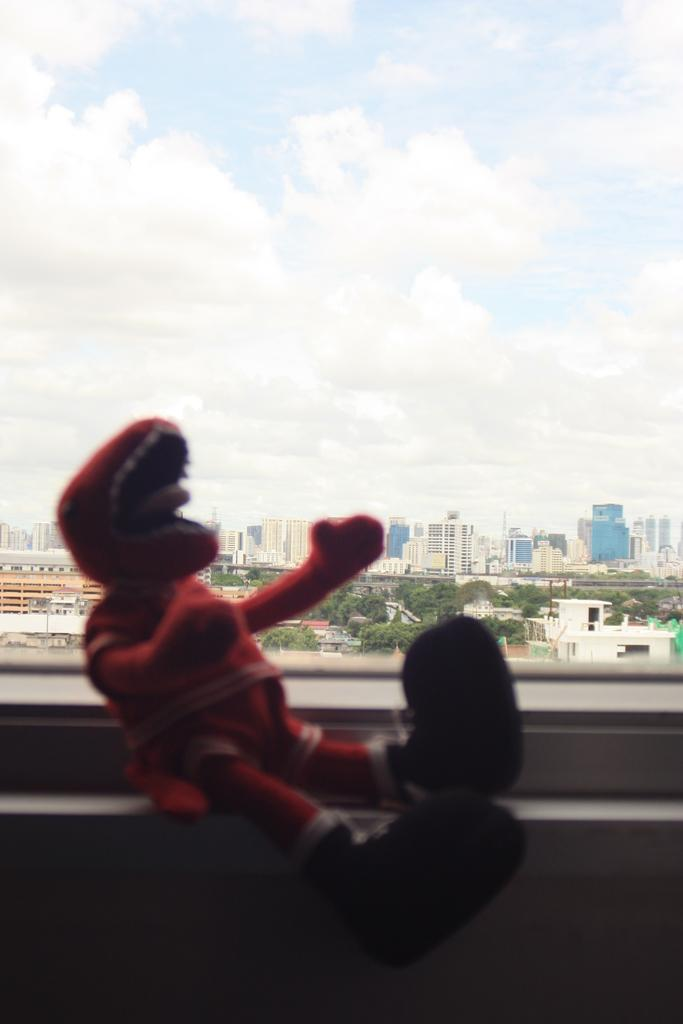What is located near the window in the image? There is a doll at the window in the image. What can be seen in the distance behind the doll? There are buildings and trees in the background of the image. What is visible at the top of the image? The sky is visible at the top of the image. What does the doll's brother think about the view from the window? There is no information about the doll having a brother or their thoughts in the image. 